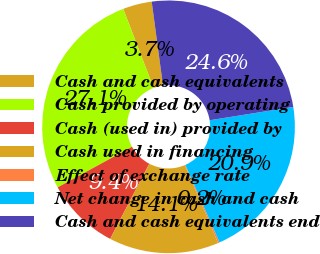<chart> <loc_0><loc_0><loc_500><loc_500><pie_chart><fcel>Cash and cash equivalents<fcel>Cash provided by operating<fcel>Cash (used in) provided by<fcel>Cash used in financing<fcel>Effect of exchange rate<fcel>Net change in cash and cash<fcel>Cash and cash equivalents end<nl><fcel>3.71%<fcel>27.12%<fcel>9.4%<fcel>14.06%<fcel>0.2%<fcel>20.9%<fcel>24.61%<nl></chart> 